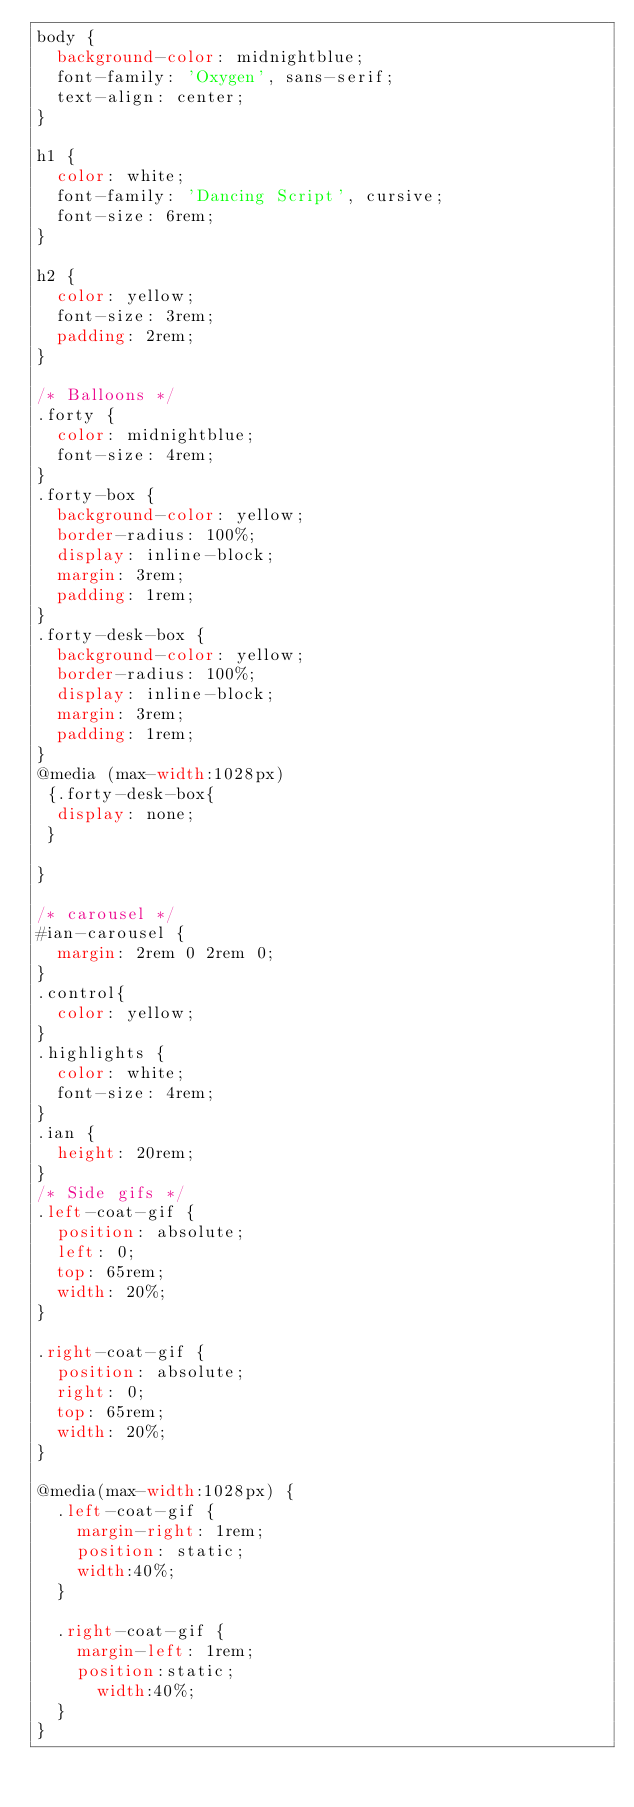Convert code to text. <code><loc_0><loc_0><loc_500><loc_500><_CSS_>body {
  background-color: midnightblue;
  font-family: 'Oxygen', sans-serif;
  text-align: center;
}

h1 {
  color: white;
  font-family: 'Dancing Script', cursive;
  font-size: 6rem;
}

h2 {
  color: yellow;
  font-size: 3rem;
  padding: 2rem;
}

/* Balloons */
.forty {
  color: midnightblue;
  font-size: 4rem;
}
.forty-box {
  background-color: yellow;
  border-radius: 100%;
  display: inline-block;
  margin: 3rem;
  padding: 1rem;
}
.forty-desk-box {
  background-color: yellow;
  border-radius: 100%;
  display: inline-block;
  margin: 3rem;
  padding: 1rem;
}
@media (max-width:1028px)
 {.forty-desk-box{
  display: none;
 }

}

/* carousel */
#ian-carousel {
  margin: 2rem 0 2rem 0;
}
.control{
  color: yellow;
}
.highlights {
  color: white;
  font-size: 4rem;
}
.ian {
  height: 20rem;
}
/* Side gifs */
.left-coat-gif {
  position: absolute;
  left: 0;
  top: 65rem;
  width: 20%;
}

.right-coat-gif {
  position: absolute;
  right: 0;
  top: 65rem;
  width: 20%;
}

@media(max-width:1028px) {
  .left-coat-gif {
    margin-right: 1rem;
    position: static;
    width:40%;
  }

  .right-coat-gif {
    margin-left: 1rem;
    position:static;
      width:40%;
  }
}
</code> 